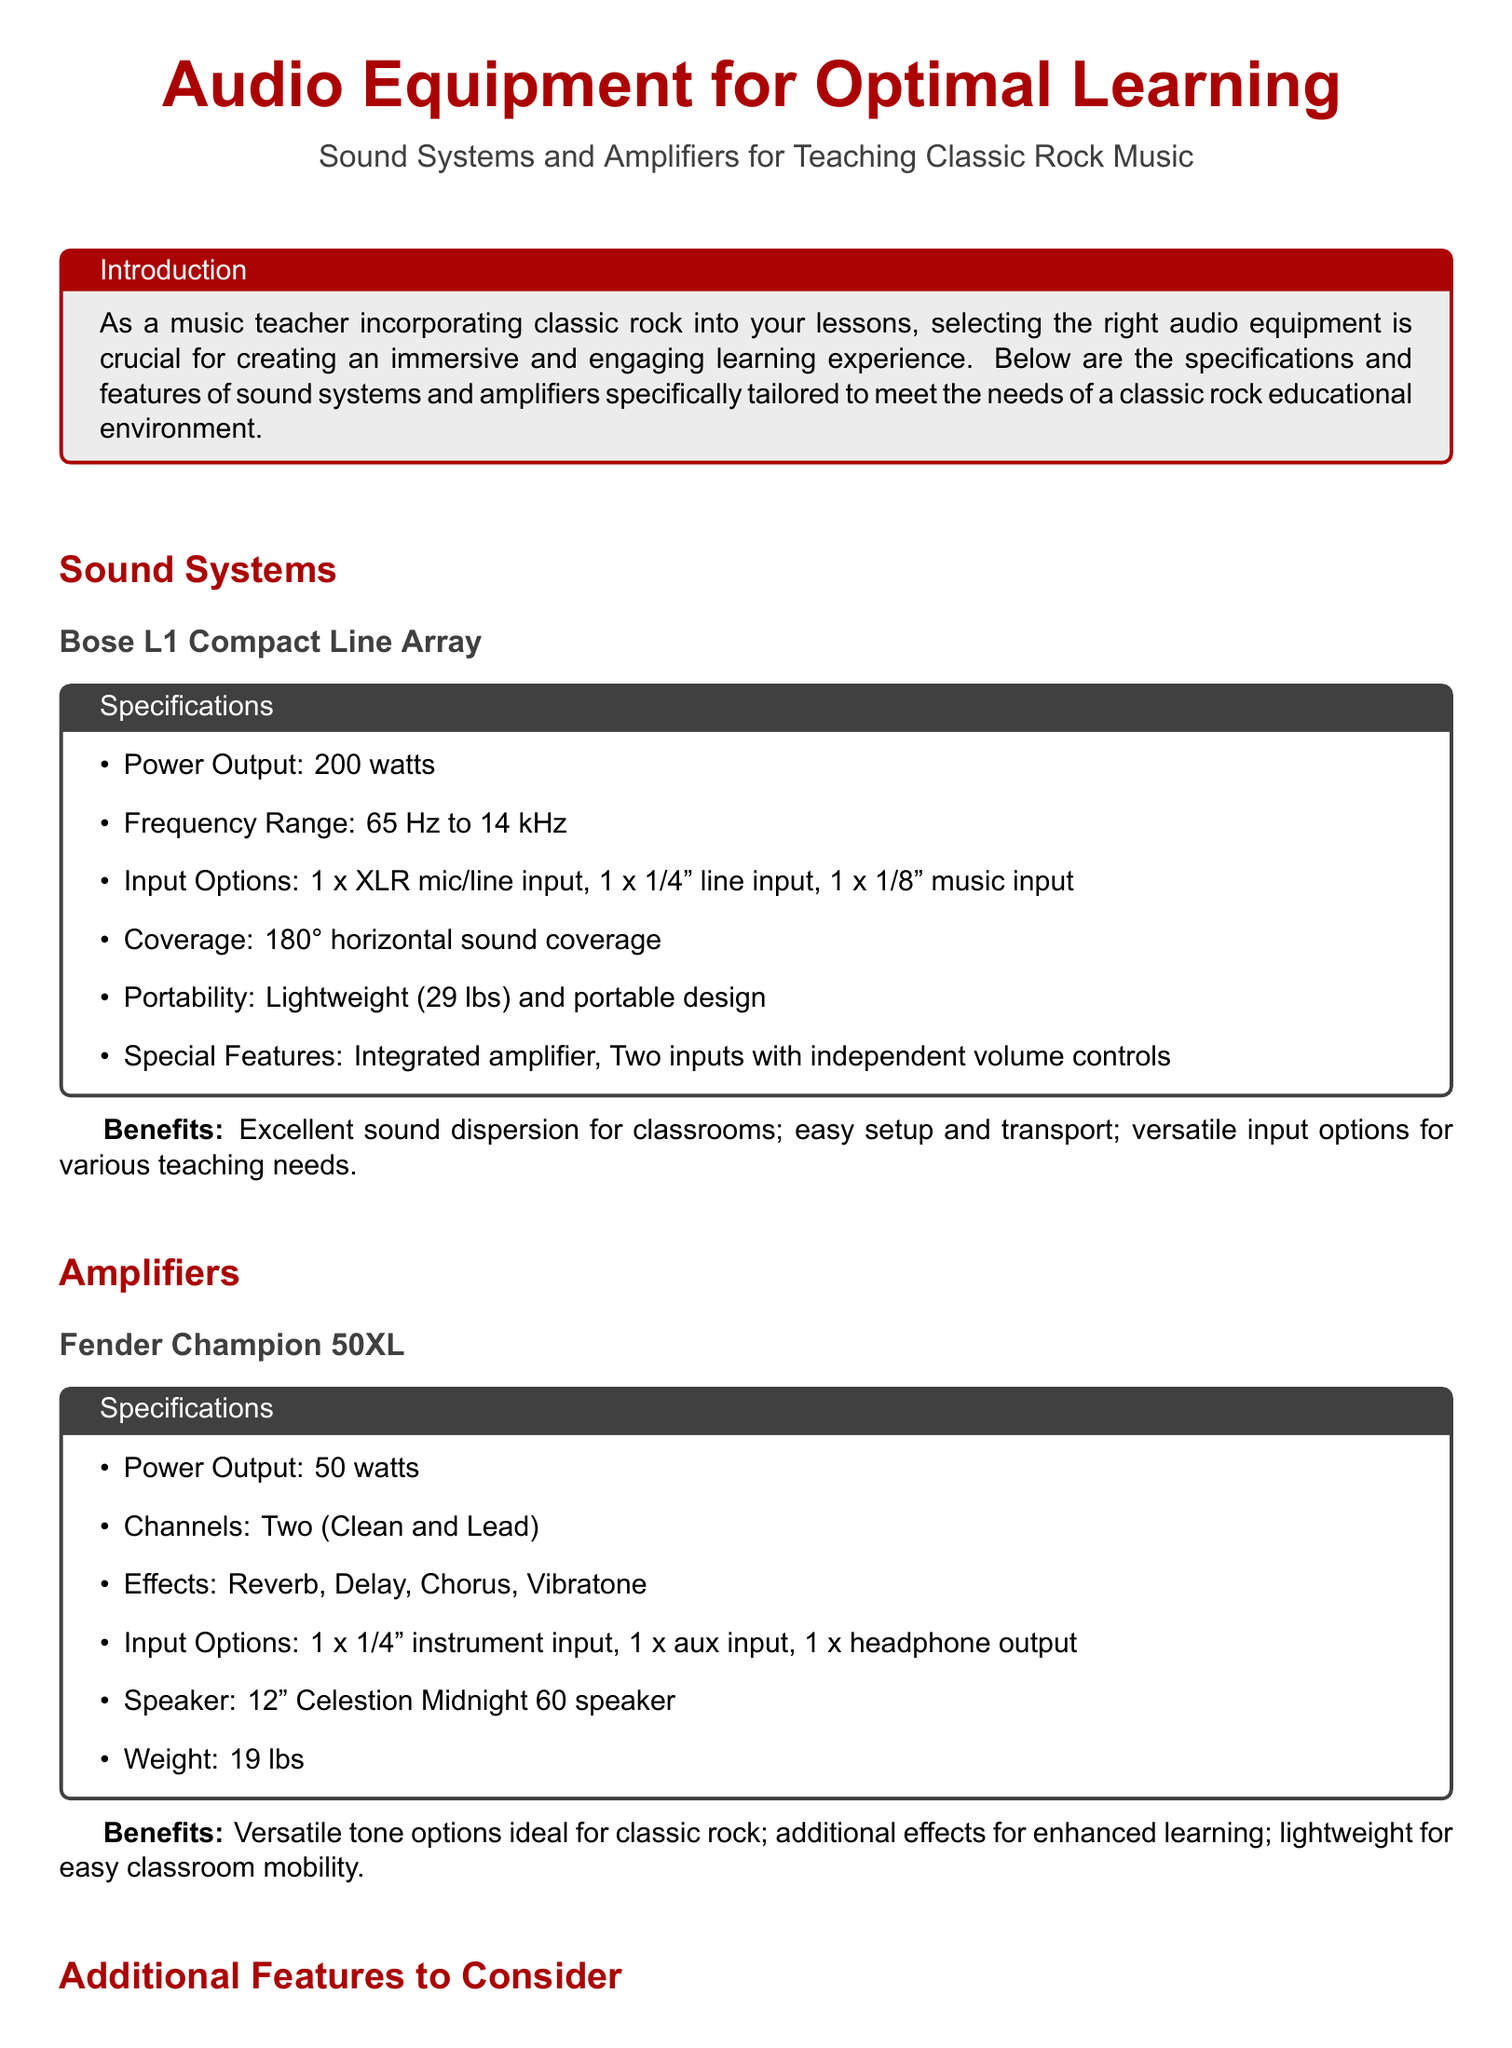What is the power output of the Bose L1 Compact Line Array? The power output is specified directly in the document as 200 watts for the Bose L1 Compact Line Array.
Answer: 200 watts What is the weight of the Fender Champion 50XL amplifier? The weight is mentioned in the specifications of the Fender Champion 50XL amplifier, which is 19 lbs.
Answer: 19 lbs What is the frequency range of the Bose L1 Compact Line Array? The frequency range is provided in the specifications as 65 Hz to 14 kHz.
Answer: 65 Hz to 14 kHz How many channels does the Yamaha MG10XU mixing console have? The document states that the Yamaha MG10XU mixing console has 10 channels.
Answer: 10 channels What type of microphone is the Shure SM58? The document specifies that the Shure SM58 is a dynamic vocal microphone.
Answer: Dynamic vocal microphone What special feature is included with the Bose L1 Compact Line Array? The document notes that it has an integrated amplifier as a special feature.
Answer: Integrated amplifier What is a notable benefit of the Fender Champion 50XL for classic rock teaching? The document states that it offers versatile tone options ideal for classic rock.
Answer: Versatile tone options How many digital effects does the Yamaha MG10XU mixing console provide? The Yamaha MG10XU mixing console provides 24 digital effects as mentioned in the document.
Answer: 24 digital effects 